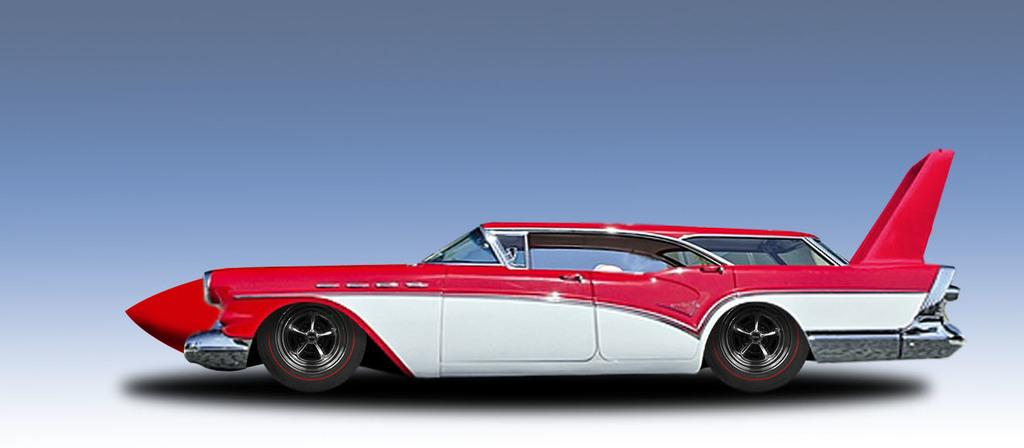What is the main object in the image? There is a toy car in the image. Can you describe the toy car's appearance? The toy car is white and red in color. What type of shoes is the toy car wearing in the image? The toy car is not wearing any shoes, as it is an inanimate object and does not have feet. 